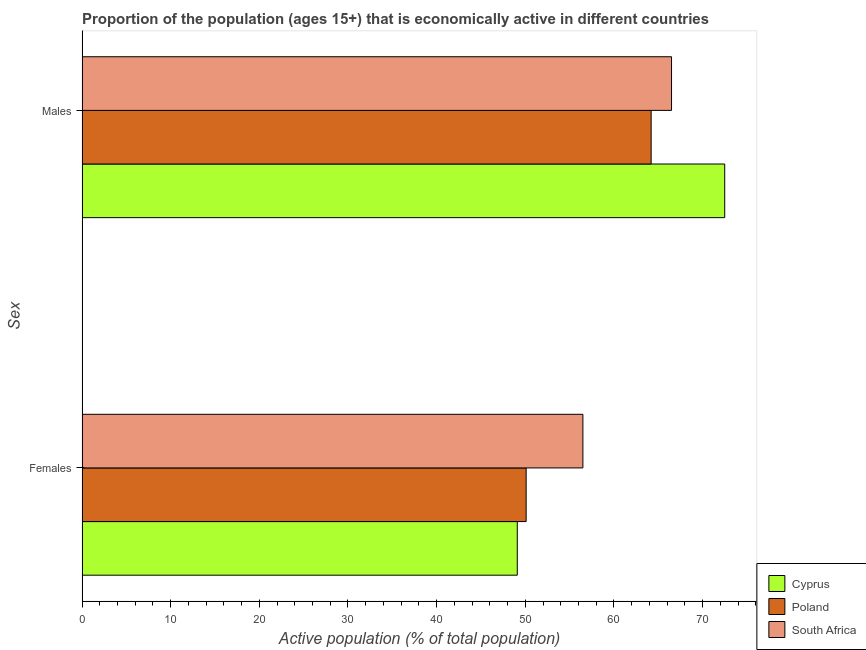How many different coloured bars are there?
Provide a succinct answer. 3. How many groups of bars are there?
Your answer should be compact. 2. Are the number of bars per tick equal to the number of legend labels?
Your response must be concise. Yes. Are the number of bars on each tick of the Y-axis equal?
Make the answer very short. Yes. How many bars are there on the 2nd tick from the bottom?
Your response must be concise. 3. What is the label of the 2nd group of bars from the top?
Your answer should be compact. Females. What is the percentage of economically active female population in Poland?
Your answer should be compact. 50.1. Across all countries, what is the maximum percentage of economically active female population?
Give a very brief answer. 56.5. Across all countries, what is the minimum percentage of economically active female population?
Provide a succinct answer. 49.1. In which country was the percentage of economically active female population maximum?
Your answer should be very brief. South Africa. In which country was the percentage of economically active female population minimum?
Your response must be concise. Cyprus. What is the total percentage of economically active female population in the graph?
Your response must be concise. 155.7. What is the difference between the percentage of economically active male population in South Africa and the percentage of economically active female population in Cyprus?
Provide a short and direct response. 17.4. What is the average percentage of economically active male population per country?
Your answer should be very brief. 67.73. What is the ratio of the percentage of economically active female population in South Africa to that in Cyprus?
Your response must be concise. 1.15. What does the 3rd bar from the top in Females represents?
Ensure brevity in your answer.  Cyprus. What does the 1st bar from the bottom in Males represents?
Give a very brief answer. Cyprus. Are the values on the major ticks of X-axis written in scientific E-notation?
Give a very brief answer. No. Does the graph contain any zero values?
Your answer should be compact. No. Does the graph contain grids?
Ensure brevity in your answer.  No. How many legend labels are there?
Give a very brief answer. 3. What is the title of the graph?
Provide a succinct answer. Proportion of the population (ages 15+) that is economically active in different countries. What is the label or title of the X-axis?
Offer a terse response. Active population (% of total population). What is the label or title of the Y-axis?
Keep it short and to the point. Sex. What is the Active population (% of total population) of Cyprus in Females?
Provide a short and direct response. 49.1. What is the Active population (% of total population) of Poland in Females?
Offer a terse response. 50.1. What is the Active population (% of total population) in South Africa in Females?
Provide a short and direct response. 56.5. What is the Active population (% of total population) of Cyprus in Males?
Make the answer very short. 72.5. What is the Active population (% of total population) of Poland in Males?
Your answer should be very brief. 64.2. What is the Active population (% of total population) of South Africa in Males?
Your answer should be very brief. 66.5. Across all Sex, what is the maximum Active population (% of total population) of Cyprus?
Provide a short and direct response. 72.5. Across all Sex, what is the maximum Active population (% of total population) in Poland?
Offer a very short reply. 64.2. Across all Sex, what is the maximum Active population (% of total population) of South Africa?
Your answer should be compact. 66.5. Across all Sex, what is the minimum Active population (% of total population) of Cyprus?
Make the answer very short. 49.1. Across all Sex, what is the minimum Active population (% of total population) in Poland?
Make the answer very short. 50.1. Across all Sex, what is the minimum Active population (% of total population) in South Africa?
Offer a very short reply. 56.5. What is the total Active population (% of total population) of Cyprus in the graph?
Provide a short and direct response. 121.6. What is the total Active population (% of total population) of Poland in the graph?
Keep it short and to the point. 114.3. What is the total Active population (% of total population) in South Africa in the graph?
Offer a very short reply. 123. What is the difference between the Active population (% of total population) of Cyprus in Females and that in Males?
Your answer should be very brief. -23.4. What is the difference between the Active population (% of total population) in Poland in Females and that in Males?
Your response must be concise. -14.1. What is the difference between the Active population (% of total population) in Cyprus in Females and the Active population (% of total population) in Poland in Males?
Make the answer very short. -15.1. What is the difference between the Active population (% of total population) in Cyprus in Females and the Active population (% of total population) in South Africa in Males?
Offer a terse response. -17.4. What is the difference between the Active population (% of total population) of Poland in Females and the Active population (% of total population) of South Africa in Males?
Your answer should be very brief. -16.4. What is the average Active population (% of total population) of Cyprus per Sex?
Your answer should be compact. 60.8. What is the average Active population (% of total population) of Poland per Sex?
Your answer should be compact. 57.15. What is the average Active population (% of total population) of South Africa per Sex?
Your answer should be very brief. 61.5. What is the difference between the Active population (% of total population) in Poland and Active population (% of total population) in South Africa in Females?
Make the answer very short. -6.4. What is the difference between the Active population (% of total population) of Cyprus and Active population (% of total population) of Poland in Males?
Keep it short and to the point. 8.3. What is the difference between the Active population (% of total population) of Cyprus and Active population (% of total population) of South Africa in Males?
Make the answer very short. 6. What is the difference between the Active population (% of total population) of Poland and Active population (% of total population) of South Africa in Males?
Your answer should be very brief. -2.3. What is the ratio of the Active population (% of total population) in Cyprus in Females to that in Males?
Make the answer very short. 0.68. What is the ratio of the Active population (% of total population) in Poland in Females to that in Males?
Make the answer very short. 0.78. What is the ratio of the Active population (% of total population) of South Africa in Females to that in Males?
Make the answer very short. 0.85. What is the difference between the highest and the second highest Active population (% of total population) of Cyprus?
Provide a succinct answer. 23.4. What is the difference between the highest and the second highest Active population (% of total population) of Poland?
Your response must be concise. 14.1. What is the difference between the highest and the second highest Active population (% of total population) of South Africa?
Offer a terse response. 10. What is the difference between the highest and the lowest Active population (% of total population) in Cyprus?
Your answer should be compact. 23.4. What is the difference between the highest and the lowest Active population (% of total population) in Poland?
Your response must be concise. 14.1. What is the difference between the highest and the lowest Active population (% of total population) of South Africa?
Offer a very short reply. 10. 